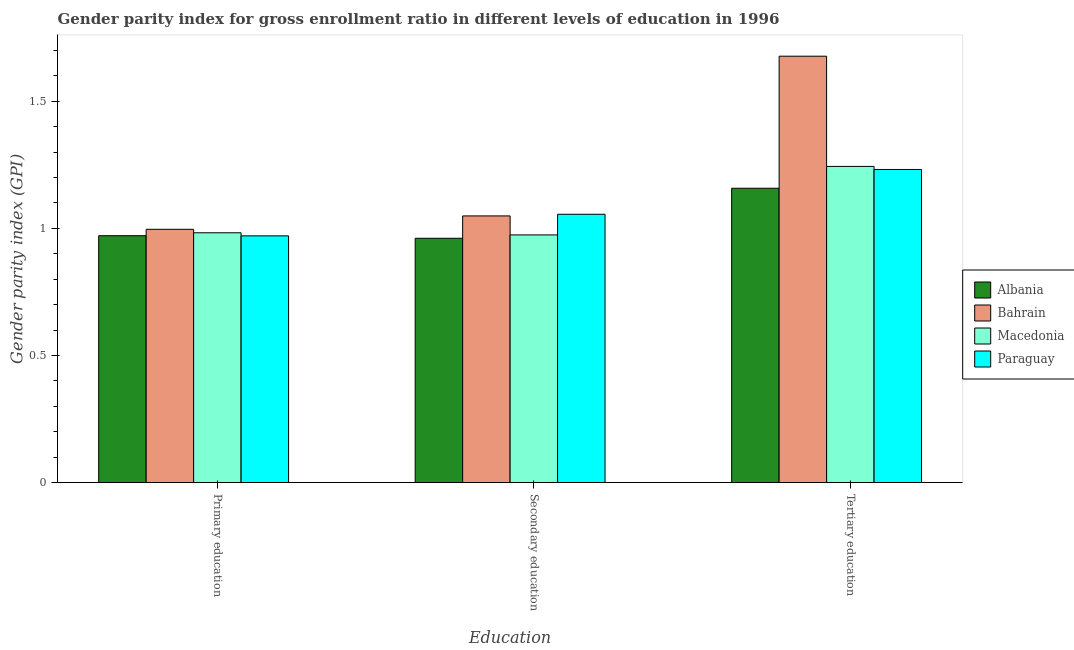How many different coloured bars are there?
Make the answer very short. 4. How many groups of bars are there?
Your answer should be compact. 3. Are the number of bars per tick equal to the number of legend labels?
Provide a succinct answer. Yes. Are the number of bars on each tick of the X-axis equal?
Offer a very short reply. Yes. How many bars are there on the 2nd tick from the left?
Provide a succinct answer. 4. How many bars are there on the 1st tick from the right?
Provide a succinct answer. 4. What is the label of the 2nd group of bars from the left?
Your answer should be very brief. Secondary education. What is the gender parity index in primary education in Bahrain?
Ensure brevity in your answer.  1. Across all countries, what is the maximum gender parity index in tertiary education?
Your response must be concise. 1.68. Across all countries, what is the minimum gender parity index in tertiary education?
Provide a short and direct response. 1.16. In which country was the gender parity index in primary education maximum?
Your response must be concise. Bahrain. In which country was the gender parity index in secondary education minimum?
Offer a very short reply. Albania. What is the total gender parity index in tertiary education in the graph?
Provide a succinct answer. 5.31. What is the difference between the gender parity index in primary education in Paraguay and that in Macedonia?
Your response must be concise. -0.01. What is the difference between the gender parity index in secondary education in Albania and the gender parity index in tertiary education in Paraguay?
Your response must be concise. -0.27. What is the average gender parity index in secondary education per country?
Your response must be concise. 1.01. What is the difference between the gender parity index in primary education and gender parity index in secondary education in Paraguay?
Keep it short and to the point. -0.08. In how many countries, is the gender parity index in primary education greater than 0.9 ?
Provide a succinct answer. 4. What is the ratio of the gender parity index in secondary education in Macedonia to that in Paraguay?
Your response must be concise. 0.92. Is the gender parity index in tertiary education in Albania less than that in Paraguay?
Your response must be concise. Yes. What is the difference between the highest and the second highest gender parity index in primary education?
Ensure brevity in your answer.  0.01. What is the difference between the highest and the lowest gender parity index in tertiary education?
Keep it short and to the point. 0.52. What does the 1st bar from the left in Tertiary education represents?
Provide a short and direct response. Albania. What does the 2nd bar from the right in Secondary education represents?
Keep it short and to the point. Macedonia. Is it the case that in every country, the sum of the gender parity index in primary education and gender parity index in secondary education is greater than the gender parity index in tertiary education?
Make the answer very short. Yes. How many countries are there in the graph?
Ensure brevity in your answer.  4. Are the values on the major ticks of Y-axis written in scientific E-notation?
Offer a terse response. No. Does the graph contain any zero values?
Offer a very short reply. No. How many legend labels are there?
Keep it short and to the point. 4. What is the title of the graph?
Keep it short and to the point. Gender parity index for gross enrollment ratio in different levels of education in 1996. What is the label or title of the X-axis?
Offer a terse response. Education. What is the label or title of the Y-axis?
Offer a very short reply. Gender parity index (GPI). What is the Gender parity index (GPI) of Albania in Primary education?
Your answer should be very brief. 0.97. What is the Gender parity index (GPI) in Bahrain in Primary education?
Keep it short and to the point. 1. What is the Gender parity index (GPI) of Macedonia in Primary education?
Give a very brief answer. 0.98. What is the Gender parity index (GPI) in Paraguay in Primary education?
Keep it short and to the point. 0.97. What is the Gender parity index (GPI) in Albania in Secondary education?
Your answer should be very brief. 0.96. What is the Gender parity index (GPI) of Bahrain in Secondary education?
Ensure brevity in your answer.  1.05. What is the Gender parity index (GPI) in Macedonia in Secondary education?
Ensure brevity in your answer.  0.97. What is the Gender parity index (GPI) in Paraguay in Secondary education?
Your response must be concise. 1.06. What is the Gender parity index (GPI) of Albania in Tertiary education?
Offer a very short reply. 1.16. What is the Gender parity index (GPI) of Bahrain in Tertiary education?
Your response must be concise. 1.68. What is the Gender parity index (GPI) in Macedonia in Tertiary education?
Provide a short and direct response. 1.24. What is the Gender parity index (GPI) in Paraguay in Tertiary education?
Ensure brevity in your answer.  1.23. Across all Education, what is the maximum Gender parity index (GPI) of Albania?
Make the answer very short. 1.16. Across all Education, what is the maximum Gender parity index (GPI) of Bahrain?
Provide a short and direct response. 1.68. Across all Education, what is the maximum Gender parity index (GPI) in Macedonia?
Provide a succinct answer. 1.24. Across all Education, what is the maximum Gender parity index (GPI) in Paraguay?
Your response must be concise. 1.23. Across all Education, what is the minimum Gender parity index (GPI) of Albania?
Offer a terse response. 0.96. Across all Education, what is the minimum Gender parity index (GPI) of Bahrain?
Provide a succinct answer. 1. Across all Education, what is the minimum Gender parity index (GPI) of Macedonia?
Provide a short and direct response. 0.97. Across all Education, what is the minimum Gender parity index (GPI) in Paraguay?
Give a very brief answer. 0.97. What is the total Gender parity index (GPI) of Albania in the graph?
Your response must be concise. 3.09. What is the total Gender parity index (GPI) in Bahrain in the graph?
Keep it short and to the point. 3.72. What is the total Gender parity index (GPI) in Macedonia in the graph?
Your response must be concise. 3.2. What is the total Gender parity index (GPI) in Paraguay in the graph?
Offer a very short reply. 3.26. What is the difference between the Gender parity index (GPI) in Albania in Primary education and that in Secondary education?
Your answer should be very brief. 0.01. What is the difference between the Gender parity index (GPI) of Bahrain in Primary education and that in Secondary education?
Provide a succinct answer. -0.05. What is the difference between the Gender parity index (GPI) of Macedonia in Primary education and that in Secondary education?
Offer a terse response. 0.01. What is the difference between the Gender parity index (GPI) of Paraguay in Primary education and that in Secondary education?
Provide a short and direct response. -0.08. What is the difference between the Gender parity index (GPI) of Albania in Primary education and that in Tertiary education?
Keep it short and to the point. -0.19. What is the difference between the Gender parity index (GPI) in Bahrain in Primary education and that in Tertiary education?
Offer a terse response. -0.68. What is the difference between the Gender parity index (GPI) in Macedonia in Primary education and that in Tertiary education?
Your answer should be compact. -0.26. What is the difference between the Gender parity index (GPI) of Paraguay in Primary education and that in Tertiary education?
Offer a terse response. -0.26. What is the difference between the Gender parity index (GPI) of Albania in Secondary education and that in Tertiary education?
Keep it short and to the point. -0.2. What is the difference between the Gender parity index (GPI) in Bahrain in Secondary education and that in Tertiary education?
Give a very brief answer. -0.63. What is the difference between the Gender parity index (GPI) of Macedonia in Secondary education and that in Tertiary education?
Provide a short and direct response. -0.27. What is the difference between the Gender parity index (GPI) of Paraguay in Secondary education and that in Tertiary education?
Make the answer very short. -0.18. What is the difference between the Gender parity index (GPI) of Albania in Primary education and the Gender parity index (GPI) of Bahrain in Secondary education?
Offer a very short reply. -0.08. What is the difference between the Gender parity index (GPI) of Albania in Primary education and the Gender parity index (GPI) of Macedonia in Secondary education?
Give a very brief answer. -0. What is the difference between the Gender parity index (GPI) in Albania in Primary education and the Gender parity index (GPI) in Paraguay in Secondary education?
Your response must be concise. -0.08. What is the difference between the Gender parity index (GPI) of Bahrain in Primary education and the Gender parity index (GPI) of Macedonia in Secondary education?
Provide a short and direct response. 0.02. What is the difference between the Gender parity index (GPI) in Bahrain in Primary education and the Gender parity index (GPI) in Paraguay in Secondary education?
Make the answer very short. -0.06. What is the difference between the Gender parity index (GPI) in Macedonia in Primary education and the Gender parity index (GPI) in Paraguay in Secondary education?
Offer a terse response. -0.07. What is the difference between the Gender parity index (GPI) in Albania in Primary education and the Gender parity index (GPI) in Bahrain in Tertiary education?
Make the answer very short. -0.71. What is the difference between the Gender parity index (GPI) of Albania in Primary education and the Gender parity index (GPI) of Macedonia in Tertiary education?
Your response must be concise. -0.27. What is the difference between the Gender parity index (GPI) in Albania in Primary education and the Gender parity index (GPI) in Paraguay in Tertiary education?
Your answer should be very brief. -0.26. What is the difference between the Gender parity index (GPI) of Bahrain in Primary education and the Gender parity index (GPI) of Macedonia in Tertiary education?
Your answer should be compact. -0.25. What is the difference between the Gender parity index (GPI) in Bahrain in Primary education and the Gender parity index (GPI) in Paraguay in Tertiary education?
Offer a terse response. -0.24. What is the difference between the Gender parity index (GPI) in Macedonia in Primary education and the Gender parity index (GPI) in Paraguay in Tertiary education?
Your answer should be compact. -0.25. What is the difference between the Gender parity index (GPI) of Albania in Secondary education and the Gender parity index (GPI) of Bahrain in Tertiary education?
Your answer should be very brief. -0.72. What is the difference between the Gender parity index (GPI) of Albania in Secondary education and the Gender parity index (GPI) of Macedonia in Tertiary education?
Ensure brevity in your answer.  -0.28. What is the difference between the Gender parity index (GPI) in Albania in Secondary education and the Gender parity index (GPI) in Paraguay in Tertiary education?
Your answer should be very brief. -0.27. What is the difference between the Gender parity index (GPI) of Bahrain in Secondary education and the Gender parity index (GPI) of Macedonia in Tertiary education?
Provide a short and direct response. -0.19. What is the difference between the Gender parity index (GPI) in Bahrain in Secondary education and the Gender parity index (GPI) in Paraguay in Tertiary education?
Your response must be concise. -0.18. What is the difference between the Gender parity index (GPI) of Macedonia in Secondary education and the Gender parity index (GPI) of Paraguay in Tertiary education?
Offer a very short reply. -0.26. What is the average Gender parity index (GPI) in Bahrain per Education?
Your answer should be compact. 1.24. What is the average Gender parity index (GPI) of Macedonia per Education?
Give a very brief answer. 1.07. What is the average Gender parity index (GPI) of Paraguay per Education?
Give a very brief answer. 1.09. What is the difference between the Gender parity index (GPI) in Albania and Gender parity index (GPI) in Bahrain in Primary education?
Offer a terse response. -0.03. What is the difference between the Gender parity index (GPI) of Albania and Gender parity index (GPI) of Macedonia in Primary education?
Provide a short and direct response. -0.01. What is the difference between the Gender parity index (GPI) in Albania and Gender parity index (GPI) in Paraguay in Primary education?
Your answer should be compact. 0. What is the difference between the Gender parity index (GPI) in Bahrain and Gender parity index (GPI) in Macedonia in Primary education?
Provide a short and direct response. 0.01. What is the difference between the Gender parity index (GPI) of Bahrain and Gender parity index (GPI) of Paraguay in Primary education?
Your response must be concise. 0.03. What is the difference between the Gender parity index (GPI) in Macedonia and Gender parity index (GPI) in Paraguay in Primary education?
Your answer should be very brief. 0.01. What is the difference between the Gender parity index (GPI) of Albania and Gender parity index (GPI) of Bahrain in Secondary education?
Your response must be concise. -0.09. What is the difference between the Gender parity index (GPI) of Albania and Gender parity index (GPI) of Macedonia in Secondary education?
Your answer should be very brief. -0.01. What is the difference between the Gender parity index (GPI) of Albania and Gender parity index (GPI) of Paraguay in Secondary education?
Keep it short and to the point. -0.09. What is the difference between the Gender parity index (GPI) of Bahrain and Gender parity index (GPI) of Macedonia in Secondary education?
Your answer should be very brief. 0.07. What is the difference between the Gender parity index (GPI) in Bahrain and Gender parity index (GPI) in Paraguay in Secondary education?
Offer a very short reply. -0.01. What is the difference between the Gender parity index (GPI) of Macedonia and Gender parity index (GPI) of Paraguay in Secondary education?
Your answer should be compact. -0.08. What is the difference between the Gender parity index (GPI) in Albania and Gender parity index (GPI) in Bahrain in Tertiary education?
Give a very brief answer. -0.52. What is the difference between the Gender parity index (GPI) of Albania and Gender parity index (GPI) of Macedonia in Tertiary education?
Give a very brief answer. -0.09. What is the difference between the Gender parity index (GPI) of Albania and Gender parity index (GPI) of Paraguay in Tertiary education?
Give a very brief answer. -0.07. What is the difference between the Gender parity index (GPI) in Bahrain and Gender parity index (GPI) in Macedonia in Tertiary education?
Provide a succinct answer. 0.43. What is the difference between the Gender parity index (GPI) in Bahrain and Gender parity index (GPI) in Paraguay in Tertiary education?
Ensure brevity in your answer.  0.45. What is the difference between the Gender parity index (GPI) of Macedonia and Gender parity index (GPI) of Paraguay in Tertiary education?
Offer a terse response. 0.01. What is the ratio of the Gender parity index (GPI) in Albania in Primary education to that in Secondary education?
Your response must be concise. 1.01. What is the ratio of the Gender parity index (GPI) in Bahrain in Primary education to that in Secondary education?
Your answer should be very brief. 0.95. What is the ratio of the Gender parity index (GPI) of Macedonia in Primary education to that in Secondary education?
Ensure brevity in your answer.  1.01. What is the ratio of the Gender parity index (GPI) in Paraguay in Primary education to that in Secondary education?
Provide a short and direct response. 0.92. What is the ratio of the Gender parity index (GPI) of Albania in Primary education to that in Tertiary education?
Ensure brevity in your answer.  0.84. What is the ratio of the Gender parity index (GPI) of Bahrain in Primary education to that in Tertiary education?
Your answer should be compact. 0.59. What is the ratio of the Gender parity index (GPI) in Macedonia in Primary education to that in Tertiary education?
Ensure brevity in your answer.  0.79. What is the ratio of the Gender parity index (GPI) of Paraguay in Primary education to that in Tertiary education?
Ensure brevity in your answer.  0.79. What is the ratio of the Gender parity index (GPI) of Albania in Secondary education to that in Tertiary education?
Provide a succinct answer. 0.83. What is the ratio of the Gender parity index (GPI) of Bahrain in Secondary education to that in Tertiary education?
Provide a short and direct response. 0.63. What is the ratio of the Gender parity index (GPI) of Macedonia in Secondary education to that in Tertiary education?
Your answer should be compact. 0.78. What is the ratio of the Gender parity index (GPI) in Paraguay in Secondary education to that in Tertiary education?
Offer a very short reply. 0.86. What is the difference between the highest and the second highest Gender parity index (GPI) of Albania?
Offer a very short reply. 0.19. What is the difference between the highest and the second highest Gender parity index (GPI) in Bahrain?
Your answer should be very brief. 0.63. What is the difference between the highest and the second highest Gender parity index (GPI) of Macedonia?
Your response must be concise. 0.26. What is the difference between the highest and the second highest Gender parity index (GPI) in Paraguay?
Offer a very short reply. 0.18. What is the difference between the highest and the lowest Gender parity index (GPI) in Albania?
Provide a succinct answer. 0.2. What is the difference between the highest and the lowest Gender parity index (GPI) of Bahrain?
Your answer should be compact. 0.68. What is the difference between the highest and the lowest Gender parity index (GPI) in Macedonia?
Make the answer very short. 0.27. What is the difference between the highest and the lowest Gender parity index (GPI) of Paraguay?
Offer a very short reply. 0.26. 